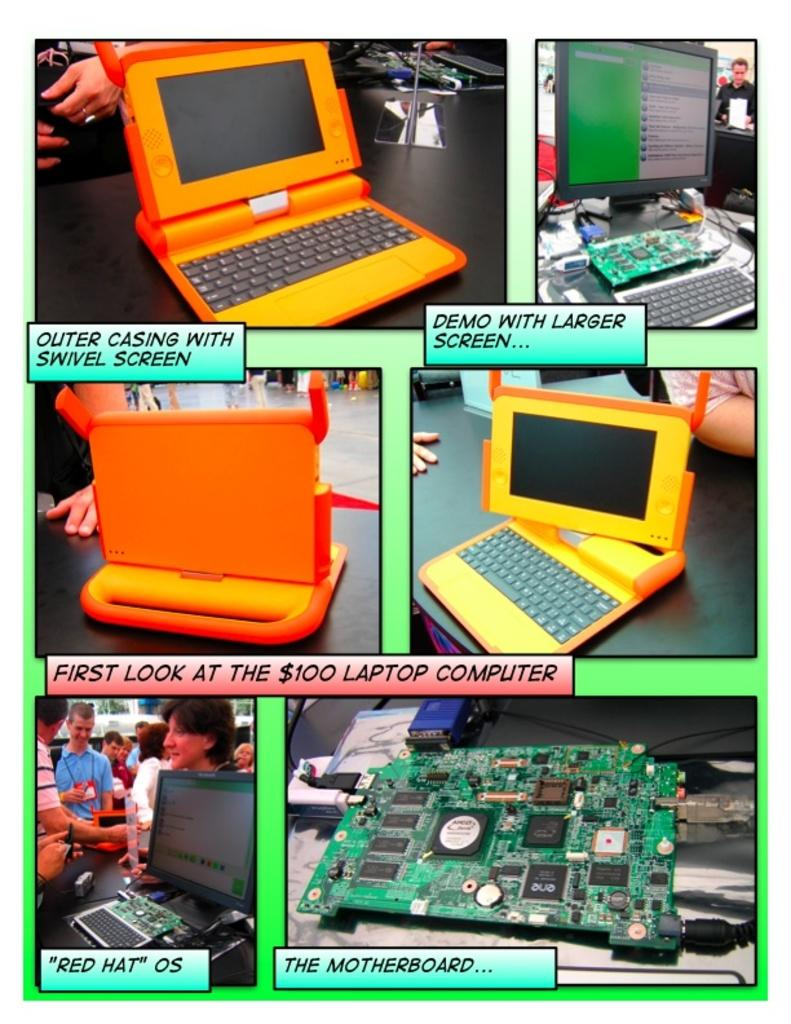Provide a one-sentence caption for the provided image. an explanation of computers with pictures with one of the labels being 'the motherboard...'. 